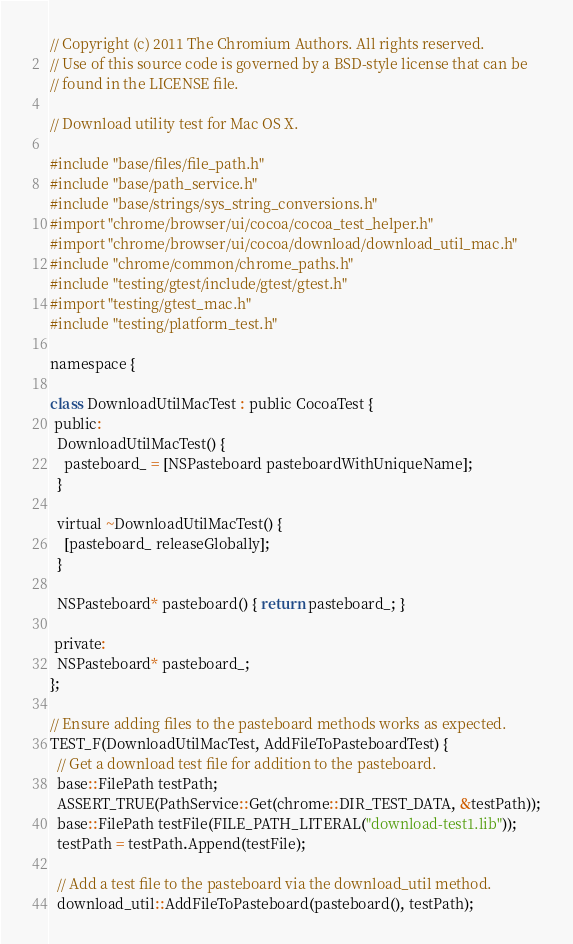Convert code to text. <code><loc_0><loc_0><loc_500><loc_500><_ObjectiveC_>// Copyright (c) 2011 The Chromium Authors. All rights reserved.
// Use of this source code is governed by a BSD-style license that can be
// found in the LICENSE file.

// Download utility test for Mac OS X.

#include "base/files/file_path.h"
#include "base/path_service.h"
#include "base/strings/sys_string_conversions.h"
#import "chrome/browser/ui/cocoa/cocoa_test_helper.h"
#import "chrome/browser/ui/cocoa/download/download_util_mac.h"
#include "chrome/common/chrome_paths.h"
#include "testing/gtest/include/gtest/gtest.h"
#import "testing/gtest_mac.h"
#include "testing/platform_test.h"

namespace {

class DownloadUtilMacTest : public CocoaTest {
 public:
  DownloadUtilMacTest() {
    pasteboard_ = [NSPasteboard pasteboardWithUniqueName];
  }

  virtual ~DownloadUtilMacTest() {
    [pasteboard_ releaseGlobally];
  }

  NSPasteboard* pasteboard() { return pasteboard_; }

 private:
  NSPasteboard* pasteboard_;
};

// Ensure adding files to the pasteboard methods works as expected.
TEST_F(DownloadUtilMacTest, AddFileToPasteboardTest) {
  // Get a download test file for addition to the pasteboard.
  base::FilePath testPath;
  ASSERT_TRUE(PathService::Get(chrome::DIR_TEST_DATA, &testPath));
  base::FilePath testFile(FILE_PATH_LITERAL("download-test1.lib"));
  testPath = testPath.Append(testFile);

  // Add a test file to the pasteboard via the download_util method.
  download_util::AddFileToPasteboard(pasteboard(), testPath);
</code> 